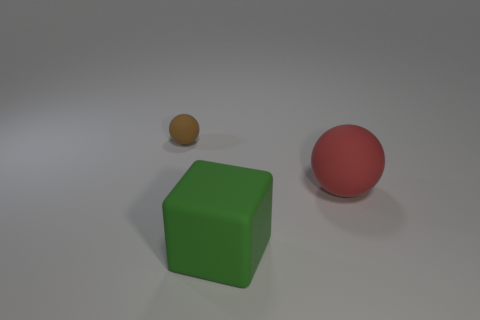What relative sizes are the objects to each other? The green cube in the image is the largest object, followed by the red sphere, which is medium-sized, and the small brown sphere is the smallest among the three. Could you infer what the size of these objects might imply if they were used in a visual metaphor? In a visual metaphor, the differing sizes could represent a hierarchy or levels of importance, with the green cube being the most significant, the red sphere as intermediate, and the small brown sphere as the least significant or foundational element. 